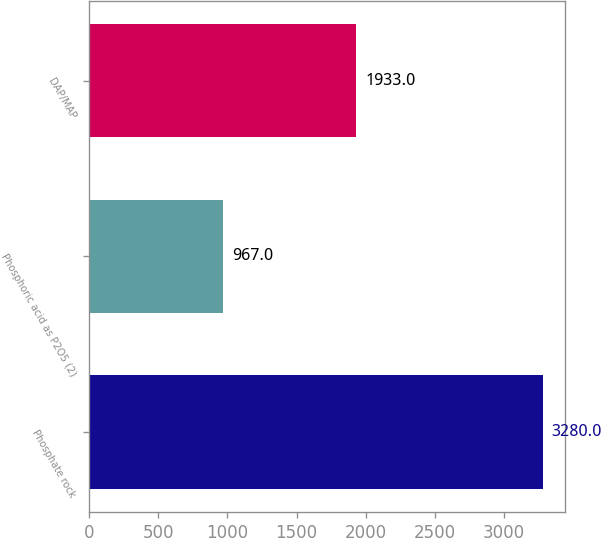Convert chart. <chart><loc_0><loc_0><loc_500><loc_500><bar_chart><fcel>Phosphate rock<fcel>Phosphoric acid as P2O5 (2)<fcel>DAP/MAP<nl><fcel>3280<fcel>967<fcel>1933<nl></chart> 